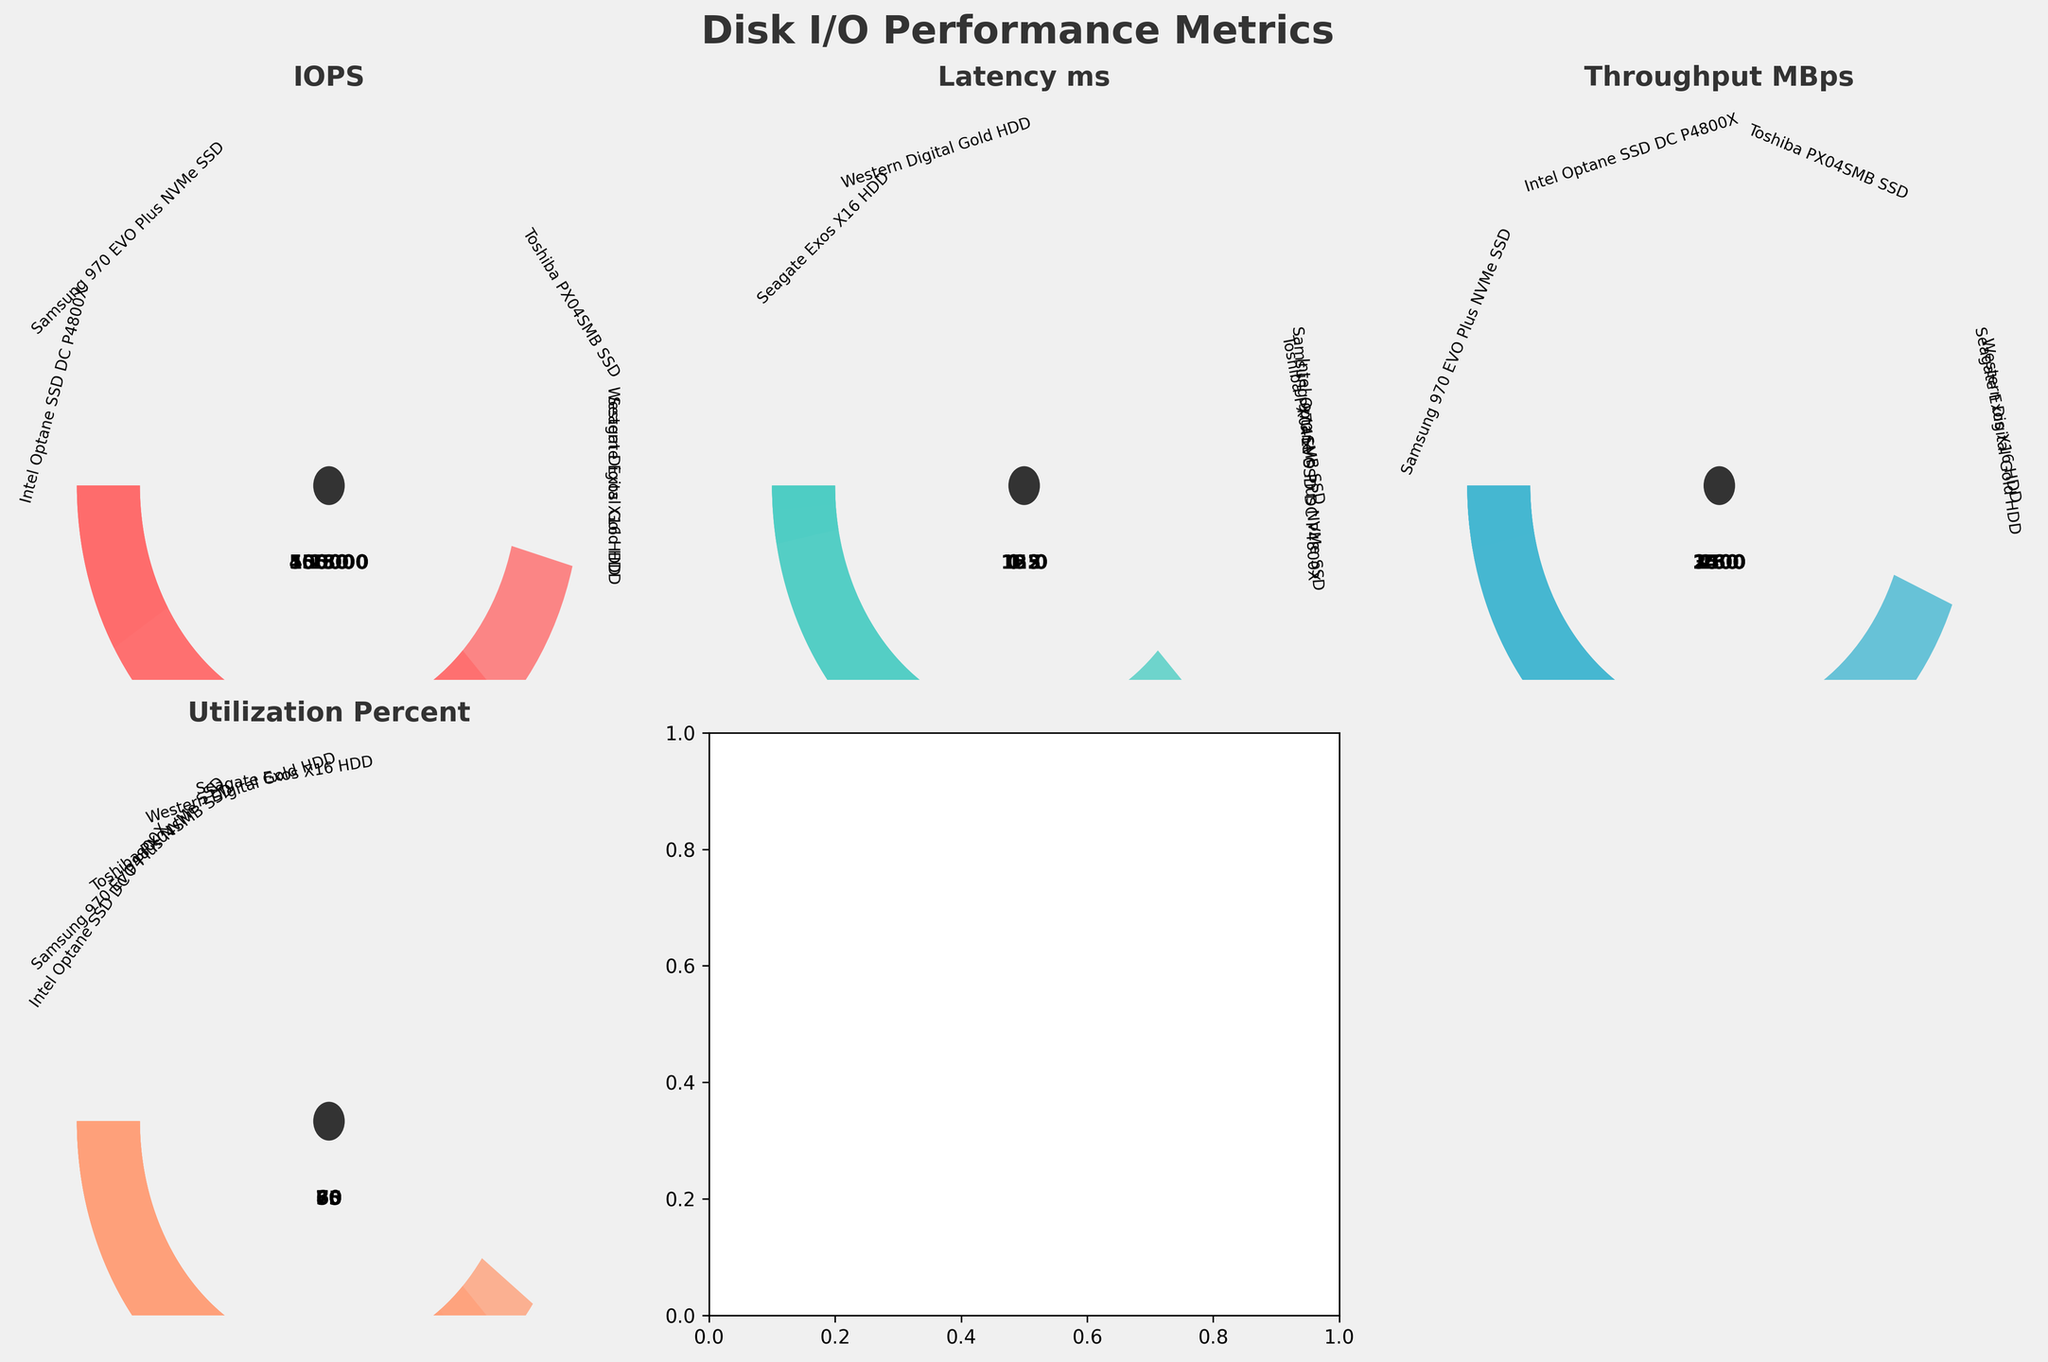What is the highest IOPS value displayed in the figure? The highest IOPS value among the devices is represented by the device with the longest arc in that gauge chart. By observing, the Intel Optane SSD DC P4800X has the longest arc, indicating the highest value.
Answer: 550000 Which device has the lowest latency in milliseconds? Latency in milliseconds is shown in one of the gauge charts. The device with the shortest arc representation within that chart has the lowest latency. Upon observing, the Intel Optane SSD DC P4800X is represented by the shortest arc, indicating the lowest latency.
Answer: Intel Optane SSD DC P4800X How many disk devices utilize more than 70%? Utilization percentage is shown in one of the gauge charts. By counting the number of arcs that span more than 70% of the total angle, we can identify the number of devices utilizing more than 70%. Only Intel Optane SSD DC P4800X (80%) and Samsung 970 EVO Plus NVMe SSD (75%) exceed 70%.
Answer: 2 Which device has the lowest throughput in MBps? The throughput in MBps gauge chart indicates device performance. The one with the smallest arc represents the lowest throughput value. Observing the arcs, Seagate Exos X16 HDD has the smallest arc, indicating the lowest throughput.
Answer: Seagate Exos X16 HDD Compare the utilization percentages of the Samsung 970 EVO Plus NVMe SSD and Western Digital Gold HDD. Which one is higher and by how much? By examining the Utilization_Percent gauge charts, we see that the Samsung 970 EVO Plus NVMe SSD's arc spans 75%, while Western Digital Gold HDD's arc spans 60%. Subtracting these values gives us the difference.
Answer: Samsung 970 EVO Plus NVMe SSD is 15% higher What is the average IOPS of the Samsung 970 EVO Plus NVMe SSD, Western Digital Gold HDD, and Toshiba PX04SMB SSD? To find the average IOPS, add the IOPS values of these three devices (450000 + 250 + 105000) and divide by 3. The sum is 555250, and dividing by 3 gives 185083.33.
Answer: 185083.33 Does any HDD device have higher throughput than Samsung 970 EVO Plus NVMe SSD? By comparing the throughput values from the chart, Samsung 970 EVO Plus NVMe SSD (3500 MBps) has higher throughput than any HDD listed (Western Digital Gold HDD: 180 MBps, Seagate Exos X16 HDD: 260 MBps), so no HDD exceeds it.
Answer: No Which metric displays the smallest value across all devices, and what is that value? By examining all gauge charts, the smallest value across all devices is found in the Latency_ms chart, represented by the smallest arc. The Intel Optane SSD DC P4800X has the smallest latency of 0.3 ms.
Answer: Latency_ms with 0.3 ms What is the combined utilization percentage for all devices? To find the combined utilization percentage, sum the Utilization_Percent values across all devices (75 + 60 + 80 + 55 + 70), which equals 340%.
Answer: 340% Which device has the second highest value of IOPS, and what is that value? By reviewing the IOPS gauge chart data, the Intel Optane SSD DC P4800X has the highest IOPS (550,000), followed by the Samsung 970 EVO Plus NVMe SSD with 450,000.
Answer: Samsung 970 EVO Plus NVMe SSD with 450000 